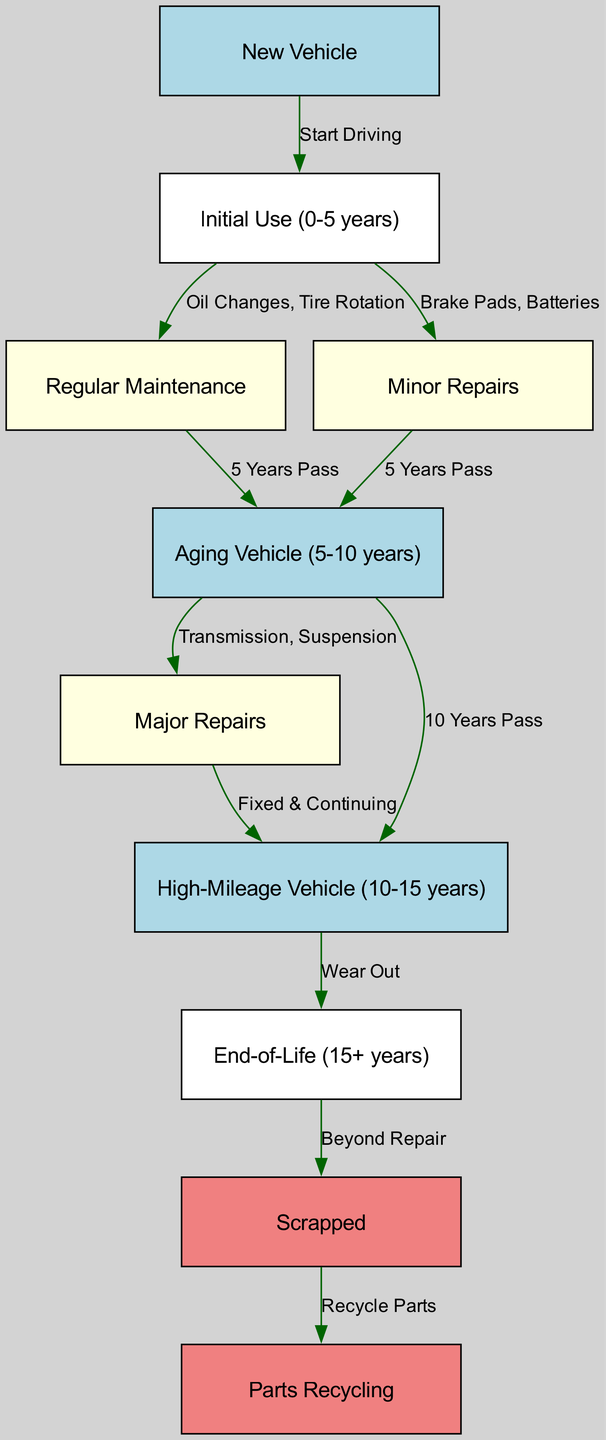What is the first step in the vehicle lifecycle? The first step in the vehicle lifecycle is indicated by the "New Vehicle" node, which is where the lifecycle begins.
Answer: New Vehicle How many nodes are in the diagram? By counting all the unique circles (nodes) representing different states or processes in the lifecycle, we find a total of 10 nodes.
Answer: 10 What leads to the "Aging Vehicle"? The transition to "Aging Vehicle" occurs after the "Regular Maintenance" or "Minor Repairs" nodes, both indicate passing of 5 years in combined use.
Answer: Regular Maintenance, Minor Repairs What is the lifespan of a "High-Mileage Vehicle"? The labeling of the "High-Mileage Vehicle" indicates it represents a vehicle that is between 10 to 15 years old, typically assessed based on mileage and wear.
Answer: 10-15 years What happens to a vehicle at "End-of-Life"? The end-of-life stage directly leads to the "Scrapped" state, indicating that the vehicle is considered beyond repair.
Answer: Scrapped What repairs are associated with the "Aging Vehicle"? During the "Aging Vehicle" phase, vehicles may undergo "Major Repairs," which include significant replacements such as transmission or suspension repairs as indicated in the diagram.
Answer: Major Repairs What is the final outcome of a scrapped vehicle? When a vehicle is scrapped, the final outcome is entering the "Parts Recycling" process, suggesting that its components may still be reused.
Answer: Parts Recycling Which node represents regular ongoing care for the vehicle? The "Regular Maintenance" node specifically addresses the scheduled upkeep tasks, including oil changes and tire rotations necessary during the initial use period.
Answer: Regular Maintenance What is required before a vehicle reaches the "High-Mileage Vehicle" stage? The vehicle must pass through the "Aging Vehicle" stage first, which occurs after significant use and maintenance efforts, before it is labeled as high-mileage.
Answer: Aging Vehicle 